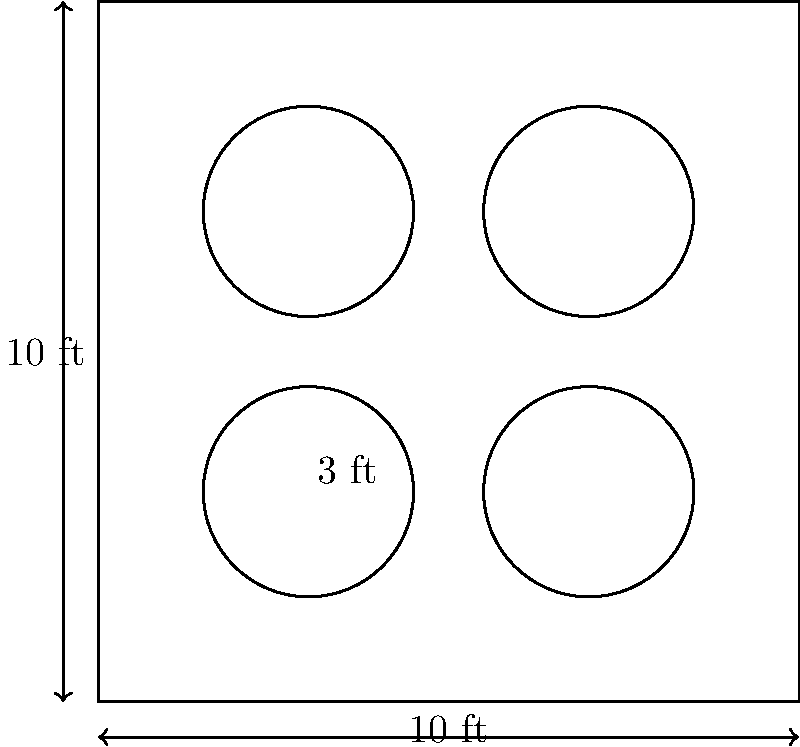A square boutique space measures 10 feet on each side. You want to place four circular display units, each with a diameter of 3 feet, in the room. What is the minimum distance between the centers of two adjacent display units to maximize floor space while maintaining a balanced layout? To solve this problem, let's follow these steps:

1. Understand the given information:
   - The room is a 10 ft × 10 ft square
   - There are four circular display units
   - Each display unit has a diameter of 3 ft (radius of 1.5 ft)

2. Consider the optimal placement:
   - To maximize floor space and maintain balance, place the units in the corners
   - This creates a square arrangement of the four units

3. Calculate the distance between centers:
   - The centers of the units form a square within the room
   - The side length of this inner square is the distance we're looking for

4. Use the Pythagorean theorem:
   - The room's diagonal = $\sqrt{10^2 + 10^2} = 10\sqrt{2}$ ft
   - The diagonal of the inner square = Room diagonal - 2 × Unit diameter
   - Inner square diagonal = $10\sqrt{2} - 2 × 3 = 10\sqrt{2} - 6$ ft

5. Calculate the side length of the inner square:
   - Let x be the side length of the inner square
   - By Pythagorean theorem: $x^2 + x^2 = (10\sqrt{2} - 6)^2$
   - Simplify: $2x^2 = 200 - 120\sqrt{2} + 36$
   - Solve: $x = \sqrt{118 - 60\sqrt{2}}$ ≈ 4 ft

Therefore, the minimum distance between the centers of two adjacent display units is approximately 4 feet.
Answer: $\sqrt{118 - 60\sqrt{2}}$ ft (≈ 4 ft) 